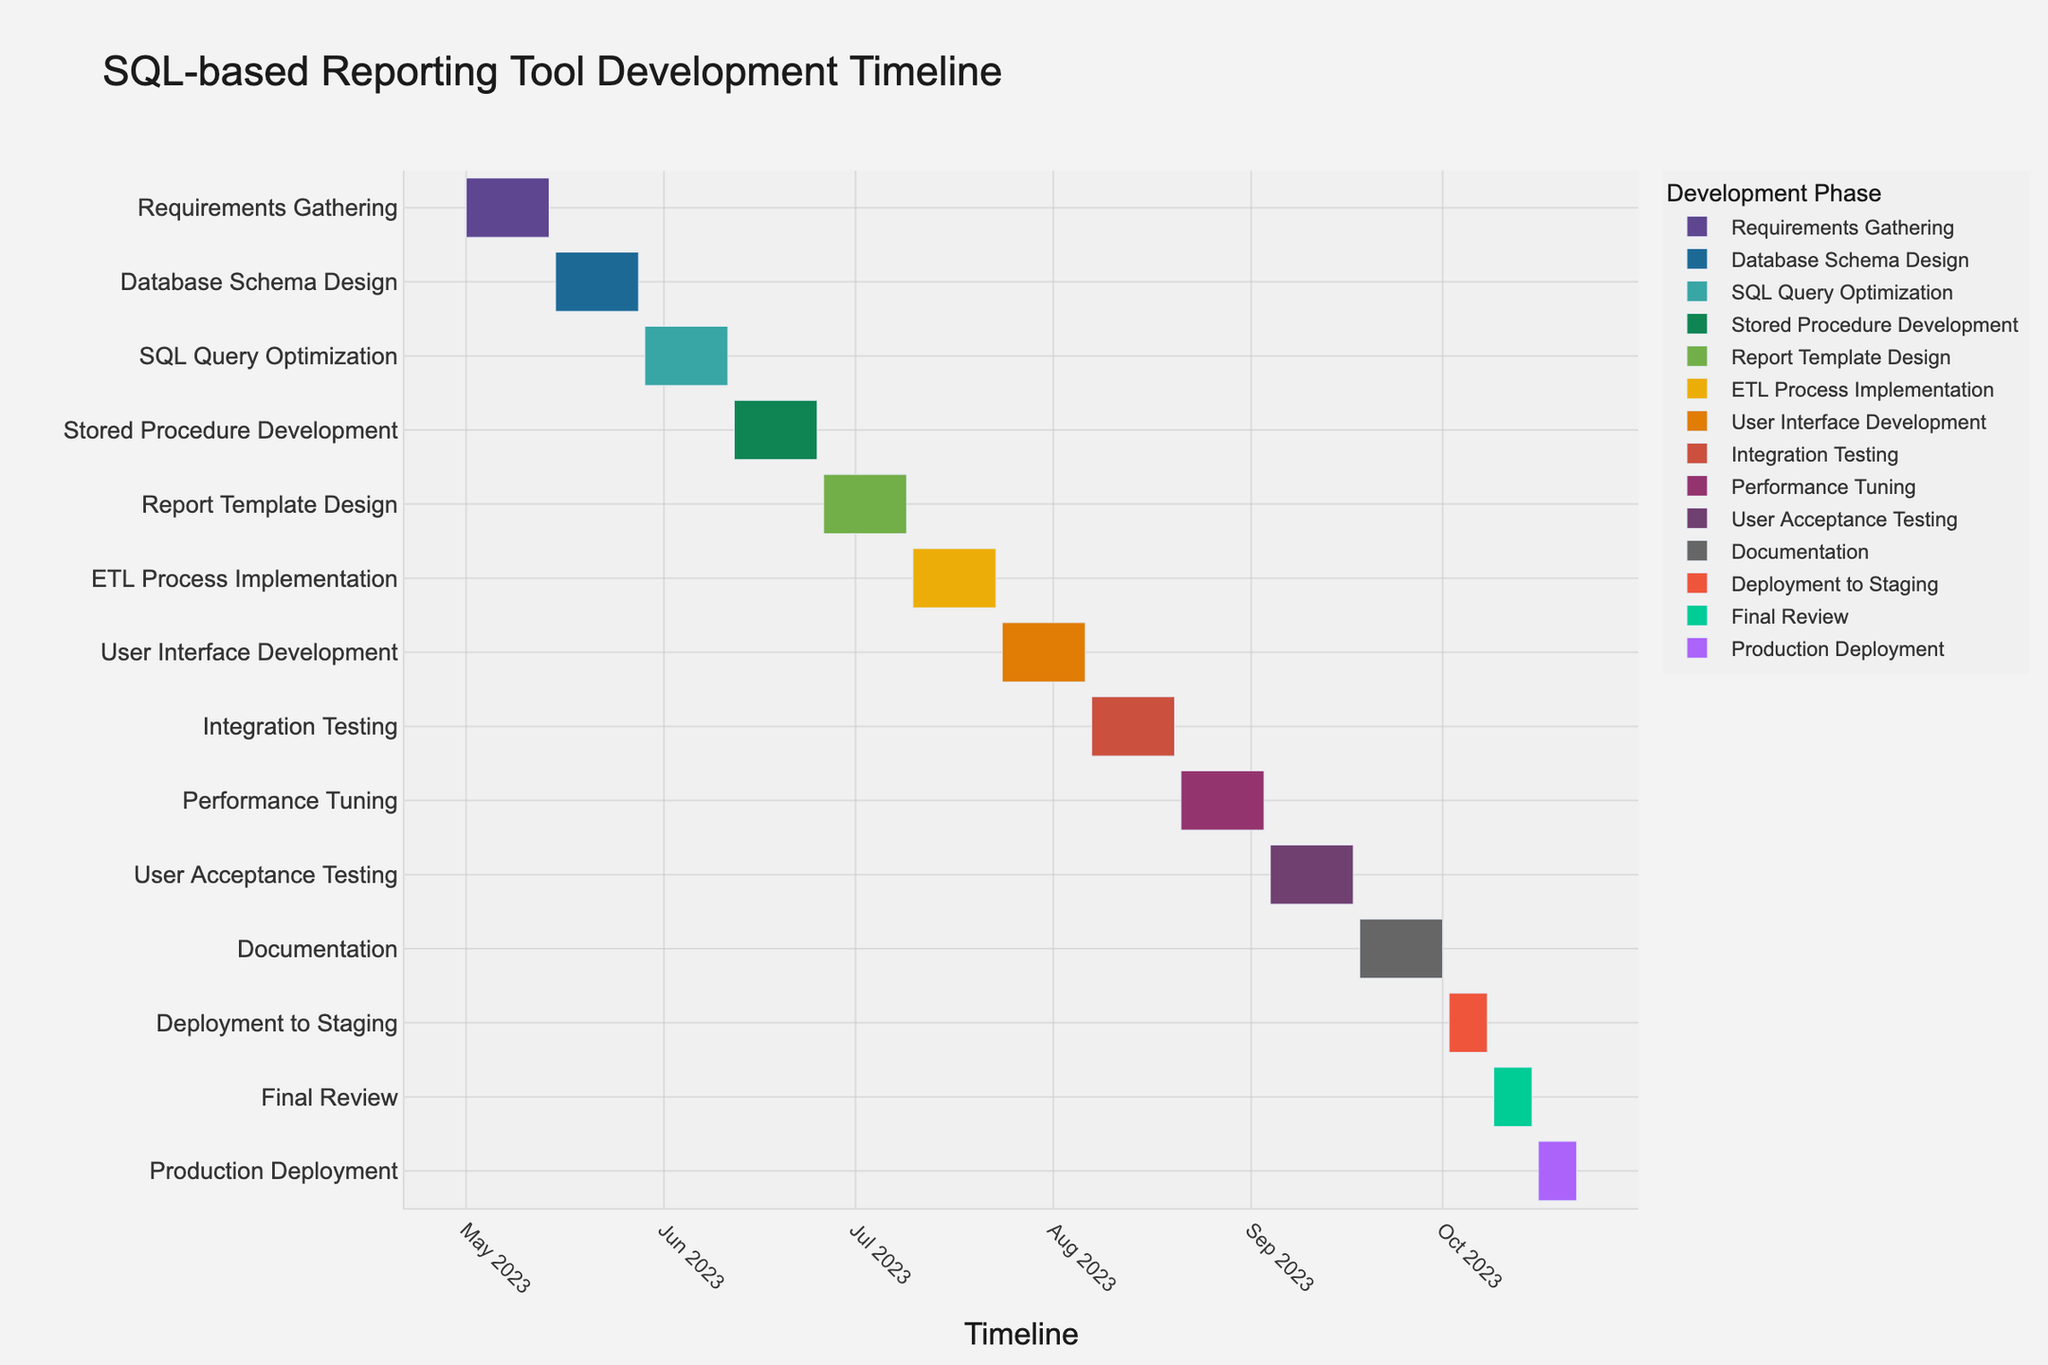What is the title of the Gantt chart? The title of the Gantt chart is located at the top of the chart. It provides a summary of the chart's content.
Answer: SQL-based Reporting Tool Development Timeline Which phase starts immediately after "Database Schema Design"? Observing the timeline on the chart, the phase starting immediately after "Database Schema Design" on 2023-05-29 is "SQL Query Optimization".
Answer: SQL Query Optimization What is the total duration required to complete "Deployment to Staging"? The duration of "Deployment to Staging" is listed directly in the data.
Answer: 7 days Which development phase has the longest duration? By looking at the durations shown on the hover data or the bar lengths on the Gantt chart, each development phase generally has 14 days, making them equal except the final three, which are shorter.
Answer: Multiple phases (14 days each) Calculate the total time from the beginning of "Requirements Gathering" to the end of "Production Deployment". Sum the durations of all tasks or take the difference between the end of "Production Deployment" and the start of "Requirements Gathering": 2023-10-22 - 2023-05-01
Answer: 175 days Which two phases occur entirely within the month of August 2023? Looking at the left axis and the timeline, the phases starting and ending in August 2023 are "Integration Testing" from 2023-08-07 to 2023-08-20, and "Performance Tuning" from 2023-08-21 to 2023-09-03.
Answer: Integration Testing and Performance Tuning How many phases are completed before "User Interface Development" starts? Count the bars that end before the start date of "User Interface Development" on 2023-07-24. There are six phases: "Requirements Gathering", "Database Schema Design", "SQL Query Optimization", "Stored Procedure Development", "Report Template Design", and "ETL Process Implementation".
Answer: 6 phases Compare the duration of "User Acceptance Testing" and "Final Review". Which one is shorter? "User Acceptance Testing" lasts for 14 days, whereas "Final Review" lasts for 7 days. Therefore, "Final Review" is shorter.
Answer: Final Review What are the last three phases before "Production Deployment"? The timeline shows the last three tasks before "Production Deployment" are "Final Review", "Deployment to Staging", and "Documentation".
Answer: Documentation, Deployment to Staging, Final Review 